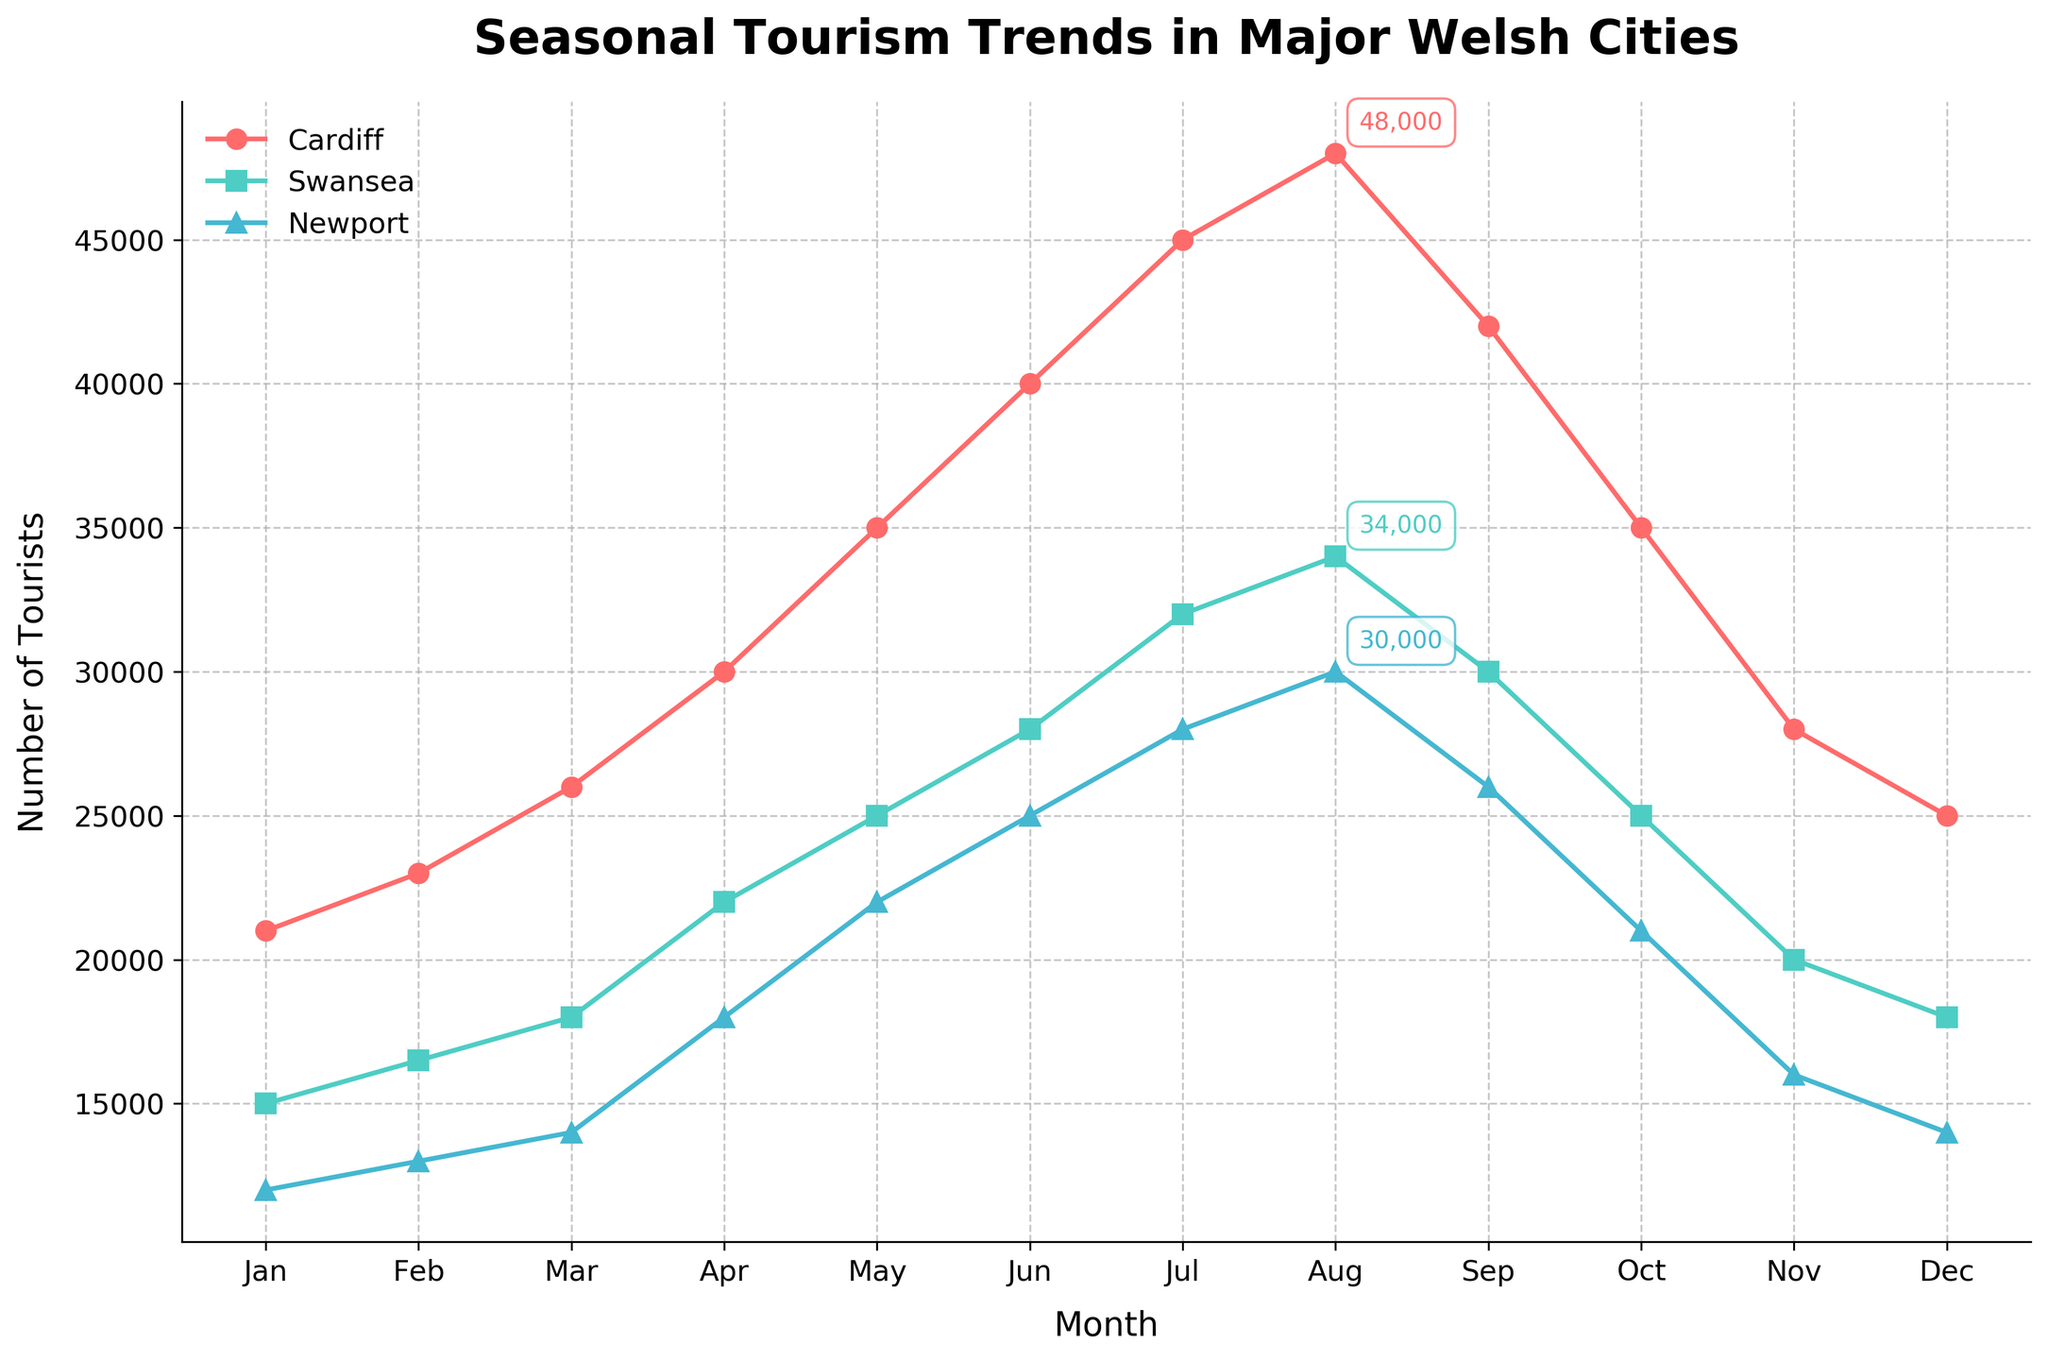What is the title of the plot? The title is usually positioned at the top of the plot in a larger and bolder font compared to other text. The title for this plot reads "Seasonal Tourism Trends in Major Welsh Cities".
Answer: Seasonal Tourism Trends in Major Welsh Cities How many cities are represented in the seasonal tourism trends plot? By looking at the legend, which typically lists all categories, three city names are listed: Cardiff, Swansea, and Newport.
Answer: 3 What colored line represents Cardiff in the plot? Each city is represented by a line of a specific color. Cardiff is represented by a red-colored line.
Answer: red During which month does Cardiff see the highest number of tourists? By following the red line towards its peak value and referencing the corresponding month on the x-axis, it's seen that Cardiff peaks in August.
Answer: August Between which two months does Swansea see the biggest increase in tourism numbers? Observing the green line for Swansea and identifying the steepest section between two months reveals the biggest increase. This happens between April and May.
Answer: April and May What is the approximate difference in the number of tourists between Newport and Cardiff in July? Identify the tourists for both Newport and Cardiff in July by looking at the peak point or marker for each city on the plot, then calculate the difference between the two numbers: 45000 (Cardiff) - 28000 (Newport) = 17000.
Answer: 17000 Which city reaches its peak number of tourists first in the year? By observing the peak points for each city and comparing their positions along the months (x-axis), it's evident that Swansea (green) peaks first among the three cities in June.
Answer: Swansea How does the number of tourists in Newport change from January to December? By tracing the green line's progress and values from January to December, it's evident that Newport starts at 12000 and ends at 14000, indicating a slight increase overall.
Answer: slight increase In which months do Cardiff and Swansea have an equal number of tourists? Track both the red and green lines and find where they intersect directly across a common month. Cardiff and Swansea have equal tourist numbers in June.
Answer: June What is the range of the number of tourists in Cardiff throughout the year? Find the highest and lowest values for Cardiff (red line) on the y-axis. The highest value is in August at 48000 and the lowest is in January at 21000, resulting in a range of 48000 - 21000 = 27000.
Answer: 27000 